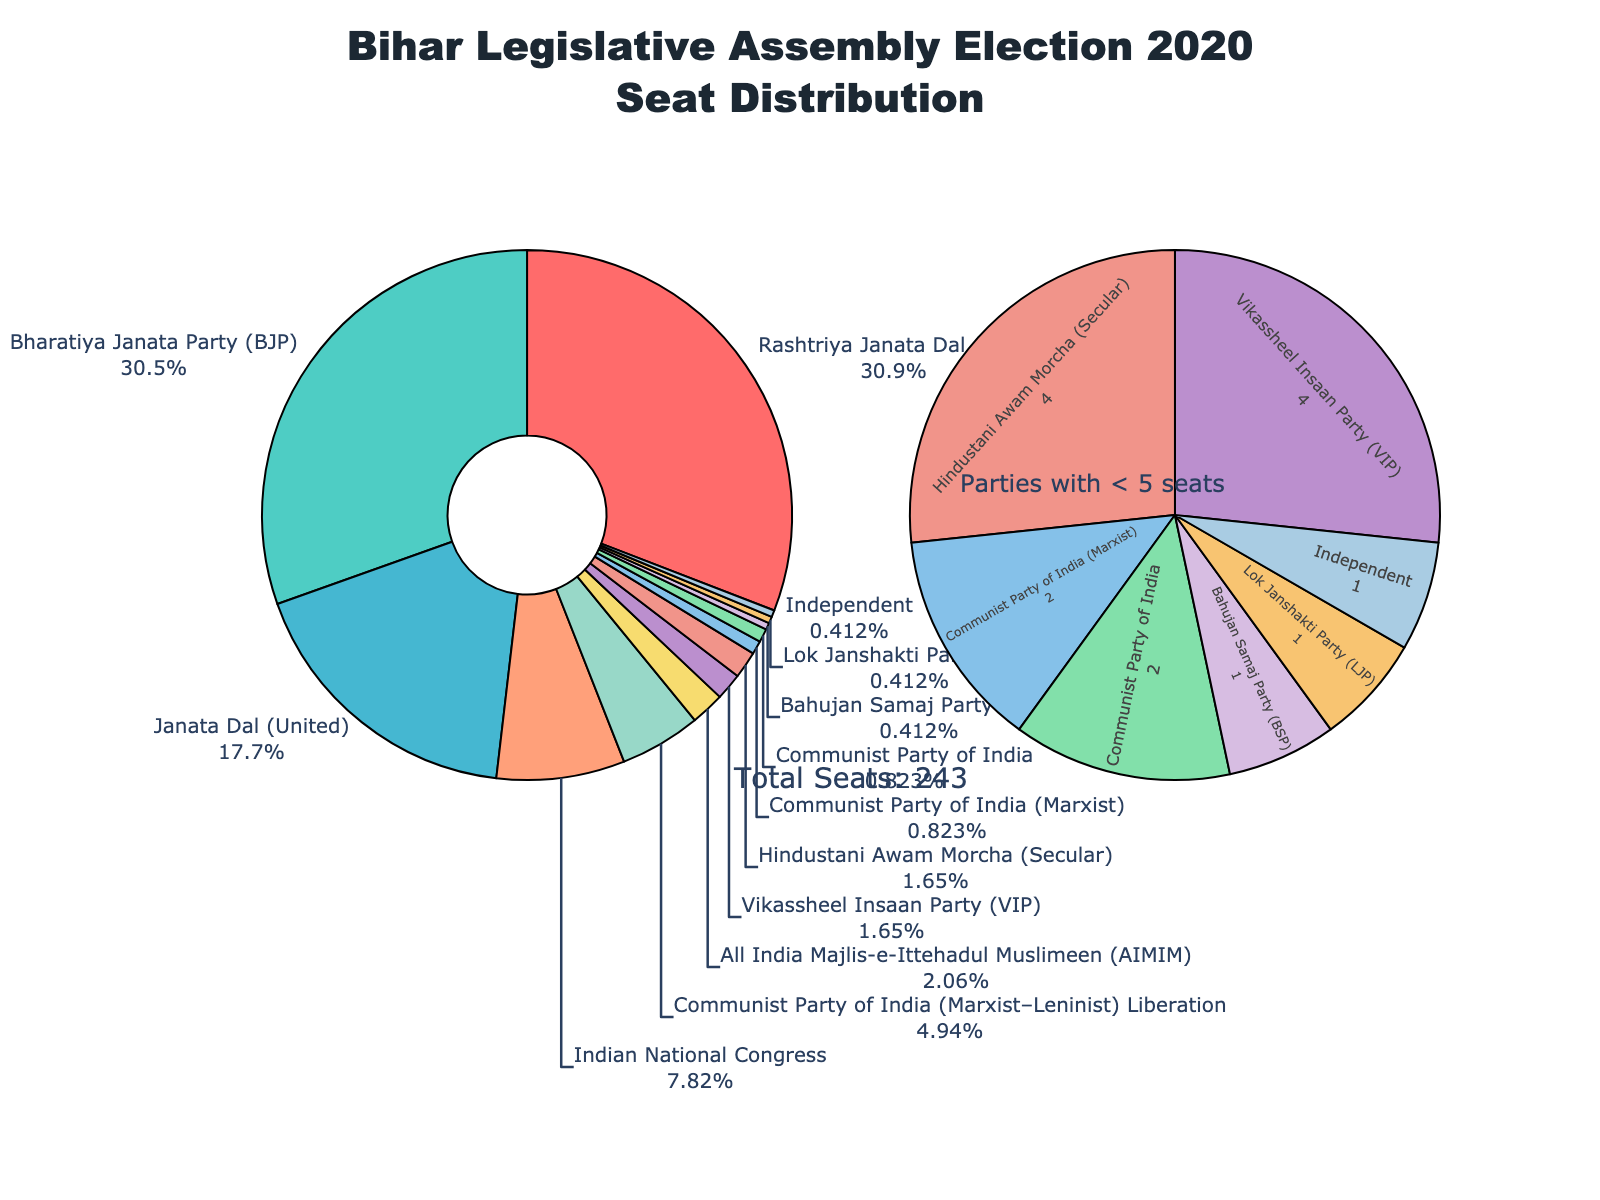Which party won the most seats in the Bihar Legislative Assembly election of 2020? According to the pie chart, Rashtriya Janata Dal (RJD) won the most seats.
Answer: Rashtriya Janata Dal (RJD) How many more seats did Rashtriya Janata Dal (RJD) win compared to Lok Janshakti Party (LJP)? Rashtriya Janata Dal (RJD) won 75 seats, and Lok Janshakti Party (LJP) won 1 seat. The difference is 75 - 1 = 74 seats.
Answer: 74 What percentage of the total seats was won by Bharatiya Janata Party (BJP)? The pie chart shows the percentages next to each party. Bharatiya Janata Party (BJP) won 74 out of 243 seats, which is around 30.45%.
Answer: 30.45% Which parties won fewer than 5 seats in total? According to the smaller pie chart section, the parties that won fewer than 5 seats are All India Majlis-e-Ittehadul Muslimeen (AIMIM), Vikassheel Insaan Party (VIP), Hindustani Awam Morcha (Secular), Communist Party of India (Marxist), Communist Party of India, Bahujan Samaj Party (BSP), Lok Janshakti Party (LJP), and Independent.
Answer: Multiple parties What is the total number of seats won by all the Communist parties combined? The Communist parties are: Communist Party of India (Marxist–Leninist) Liberation with 12 seats, Communist Party of India (2 seats), and Communist Party of India (Marxist) (2 seats). The total is 12 + 2 + 2 = 16 seats.
Answer: 16 Which party is visually represented by the shade of dark red on the chart? The party represented by dark red on the chart is Rashtriya Janata Dal (RJD).
Answer: Rashtriya Janata Dal (RJD) How many parties won exactly 1 seat each? According to the smaller pie chart, the parties that won exactly 1 seat each are Bahujan Samaj Party (BSP), Lok Janshakti Party (LJP), and Independent. Therefore, there are 3 such parties.
Answer: 3 Considering only the parties that won more than 10 seats, what is the average number of seats won by these parties? The parties that won more than 10 seats are RJD (75), BJP (74), Janata Dal (United) (43), Indian National Congress (19), and Communist Party of India (Marxist–Leninist) Liberation (12). The average is (75+74+43+19+12) / 5 = 223 / 5 = 44.6 seats.
Answer: 44.6 